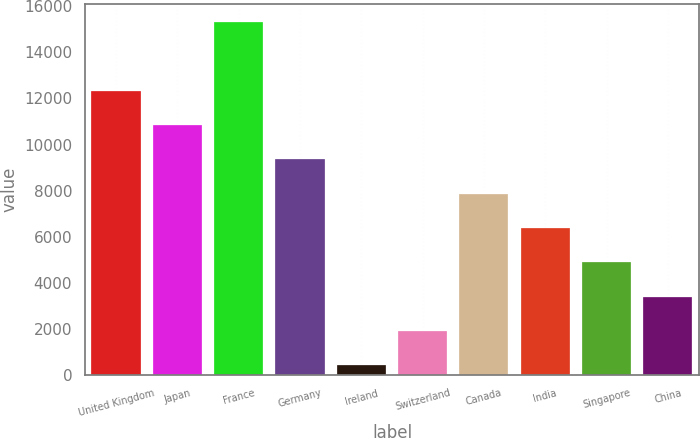Convert chart to OTSL. <chart><loc_0><loc_0><loc_500><loc_500><bar_chart><fcel>United Kingdom<fcel>Japan<fcel>France<fcel>Germany<fcel>Ireland<fcel>Switzerland<fcel>Canada<fcel>India<fcel>Singapore<fcel>China<nl><fcel>12339<fcel>10848<fcel>15321<fcel>9357<fcel>411<fcel>1902<fcel>7866<fcel>6375<fcel>4884<fcel>3393<nl></chart> 